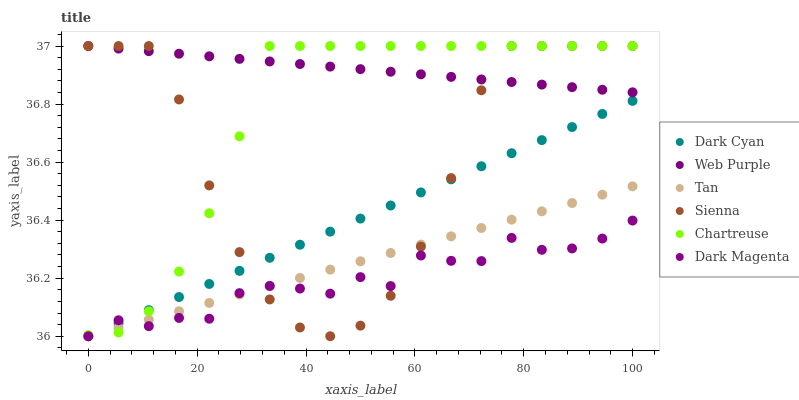Does Dark Magenta have the minimum area under the curve?
Answer yes or no. Yes. Does Web Purple have the maximum area under the curve?
Answer yes or no. Yes. Does Chartreuse have the minimum area under the curve?
Answer yes or no. No. Does Chartreuse have the maximum area under the curve?
Answer yes or no. No. Is Web Purple the smoothest?
Answer yes or no. Yes. Is Sienna the roughest?
Answer yes or no. Yes. Is Chartreuse the smoothest?
Answer yes or no. No. Is Chartreuse the roughest?
Answer yes or no. No. Does Dark Magenta have the lowest value?
Answer yes or no. Yes. Does Chartreuse have the lowest value?
Answer yes or no. No. Does Web Purple have the highest value?
Answer yes or no. Yes. Does Dark Cyan have the highest value?
Answer yes or no. No. Is Dark Cyan less than Web Purple?
Answer yes or no. Yes. Is Web Purple greater than Tan?
Answer yes or no. Yes. Does Dark Cyan intersect Chartreuse?
Answer yes or no. Yes. Is Dark Cyan less than Chartreuse?
Answer yes or no. No. Is Dark Cyan greater than Chartreuse?
Answer yes or no. No. Does Dark Cyan intersect Web Purple?
Answer yes or no. No. 